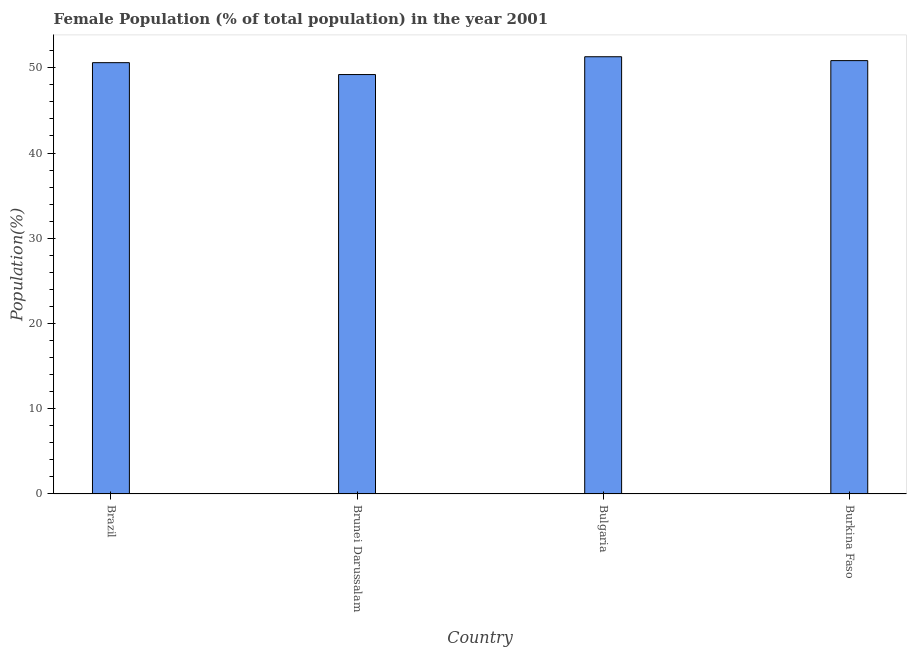What is the title of the graph?
Your answer should be very brief. Female Population (% of total population) in the year 2001. What is the label or title of the X-axis?
Provide a short and direct response. Country. What is the label or title of the Y-axis?
Offer a very short reply. Population(%). What is the female population in Brazil?
Your answer should be very brief. 50.6. Across all countries, what is the maximum female population?
Offer a terse response. 51.3. Across all countries, what is the minimum female population?
Provide a succinct answer. 49.21. In which country was the female population minimum?
Make the answer very short. Brunei Darussalam. What is the sum of the female population?
Your response must be concise. 201.95. What is the difference between the female population in Brunei Darussalam and Bulgaria?
Your answer should be compact. -2.09. What is the average female population per country?
Provide a succinct answer. 50.49. What is the median female population?
Your response must be concise. 50.72. What is the ratio of the female population in Bulgaria to that in Burkina Faso?
Provide a succinct answer. 1.01. Is the female population in Brunei Darussalam less than that in Burkina Faso?
Offer a terse response. Yes. Is the difference between the female population in Brazil and Brunei Darussalam greater than the difference between any two countries?
Provide a short and direct response. No. What is the difference between the highest and the second highest female population?
Offer a terse response. 0.46. What is the difference between the highest and the lowest female population?
Ensure brevity in your answer.  2.09. How many countries are there in the graph?
Keep it short and to the point. 4. What is the difference between two consecutive major ticks on the Y-axis?
Keep it short and to the point. 10. Are the values on the major ticks of Y-axis written in scientific E-notation?
Your response must be concise. No. What is the Population(%) in Brazil?
Provide a short and direct response. 50.6. What is the Population(%) of Brunei Darussalam?
Make the answer very short. 49.21. What is the Population(%) of Bulgaria?
Offer a terse response. 51.3. What is the Population(%) in Burkina Faso?
Give a very brief answer. 50.84. What is the difference between the Population(%) in Brazil and Brunei Darussalam?
Your answer should be compact. 1.39. What is the difference between the Population(%) in Brazil and Bulgaria?
Your answer should be compact. -0.69. What is the difference between the Population(%) in Brazil and Burkina Faso?
Your answer should be very brief. -0.24. What is the difference between the Population(%) in Brunei Darussalam and Bulgaria?
Provide a short and direct response. -2.09. What is the difference between the Population(%) in Brunei Darussalam and Burkina Faso?
Provide a succinct answer. -1.63. What is the difference between the Population(%) in Bulgaria and Burkina Faso?
Provide a short and direct response. 0.46. What is the ratio of the Population(%) in Brazil to that in Brunei Darussalam?
Provide a short and direct response. 1.03. What is the ratio of the Population(%) in Brazil to that in Bulgaria?
Provide a succinct answer. 0.99. What is the ratio of the Population(%) in Brazil to that in Burkina Faso?
Your answer should be very brief. 0.99. What is the ratio of the Population(%) in Brunei Darussalam to that in Bulgaria?
Provide a succinct answer. 0.96. 